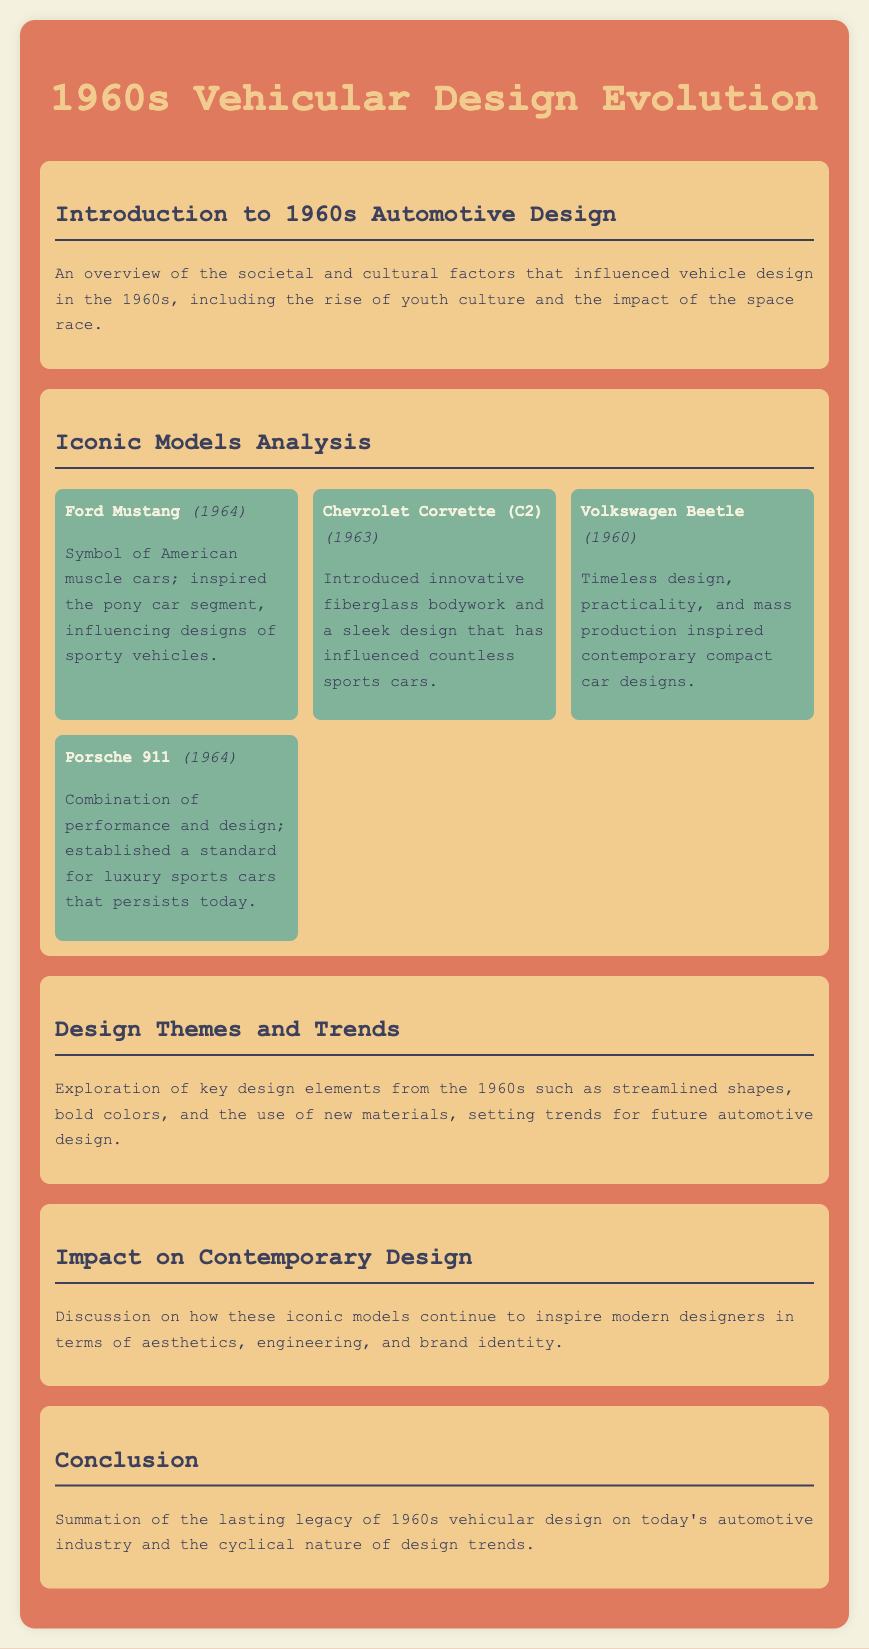What is the first vehicle model analyzed in the document? The first vehicle model listed under Iconic Models Analysis is the Ford Mustang.
Answer: Ford Mustang In what year was the Chevrolet Corvette (C2) introduced? The Chevrolet Corvette (C2) was introduced in 1963.
Answer: 1963 What design element from the 1960s set trends for future automotive design? Streamlined shapes, bold colors, and the use of new materials are key design elements from the 1960s.
Answer: Streamlined shapes, bold colors, and the use of new materials Which vehicle is described as a symbol of American muscle cars? The vehicle described as a symbol of American muscle cars is the Ford Mustang.
Answer: Ford Mustang How did the Volkswagen Beetle influence contemporary designs? The Volkswagen Beetle inspired contemporary compact car designs due to its timeless design and mass production.
Answer: Compact car designs What is the main focus of the section "Impact on Contemporary Design"? The section discusses how iconic models continue to inspire modern designers in aesthetics, engineering, and brand identity.
Answer: Modern designers What is summarized in the conclusion of the document? The conclusion summarizes the lasting legacy of 1960s vehicular design on today's automotive industry.
Answer: Lasting legacy of 1960s vehicular design What color is predominantly featured in the document's background? The background color used throughout the document is a light beige color (#f4f1de).
Answer: Light beige How many iconic vehicle models are analyzed in the document? There are four iconic vehicle models analyzed in the document.
Answer: Four 